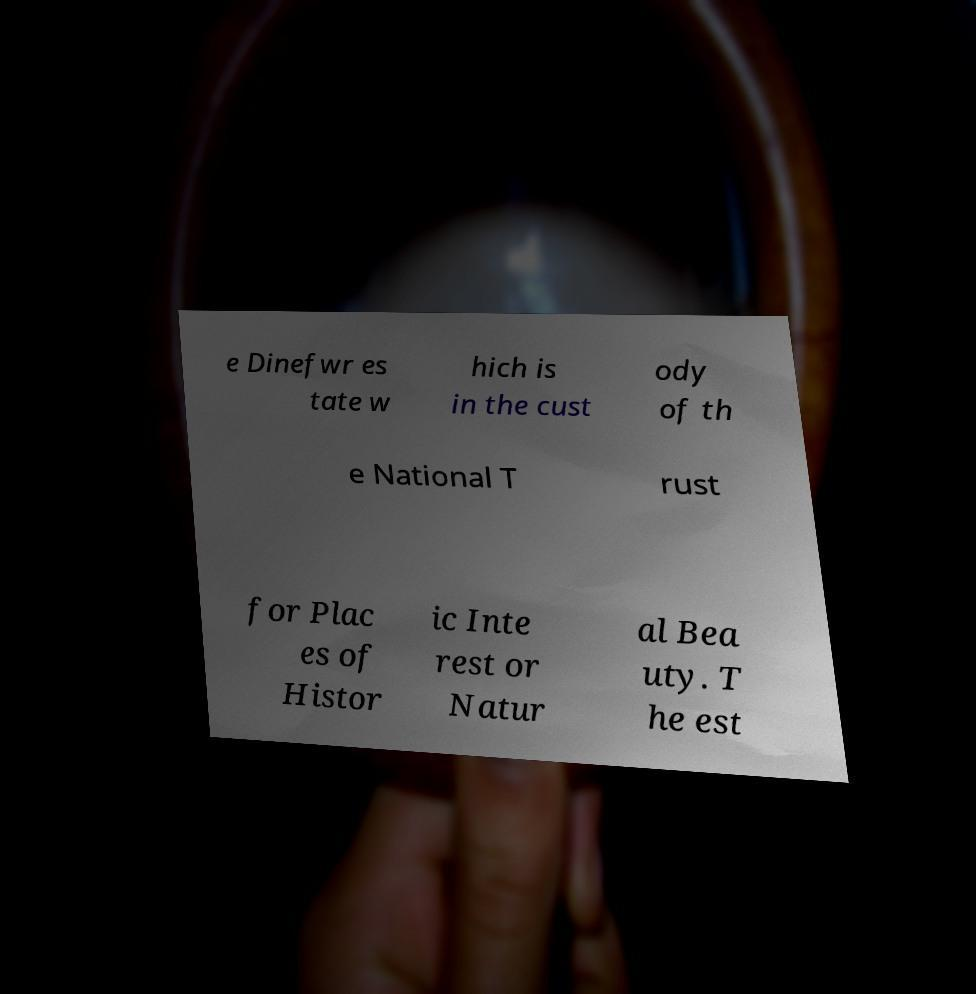I need the written content from this picture converted into text. Can you do that? e Dinefwr es tate w hich is in the cust ody of th e National T rust for Plac es of Histor ic Inte rest or Natur al Bea uty. T he est 